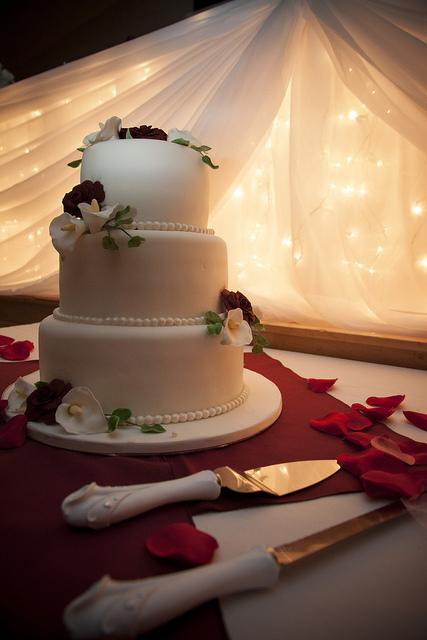Which kind of relationship is this cake typically designed for?

Choices:
A) friendship
B) acquaintanceship
C) familial
D) romantic romantic 